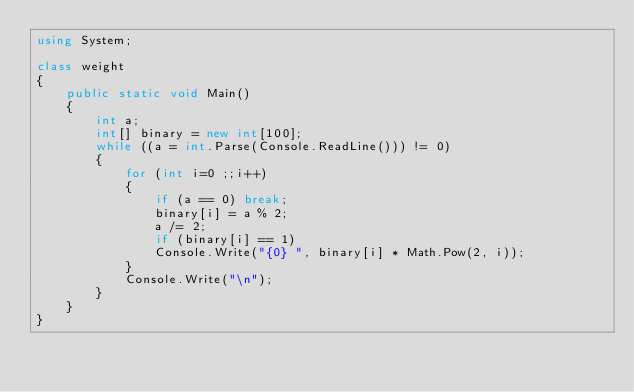<code> <loc_0><loc_0><loc_500><loc_500><_C#_>using System;

class weight
{
    public static void Main()
    {
        int a;
        int[] binary = new int[100];
        while ((a = int.Parse(Console.ReadLine())) != 0)
        {
            for (int i=0 ;;i++)
            {
                if (a == 0) break;
                binary[i] = a % 2;
                a /= 2;
                if (binary[i] == 1) 
                Console.Write("{0} ", binary[i] * Math.Pow(2, i));
            }
            Console.Write("\n");
        }
    }
}</code> 